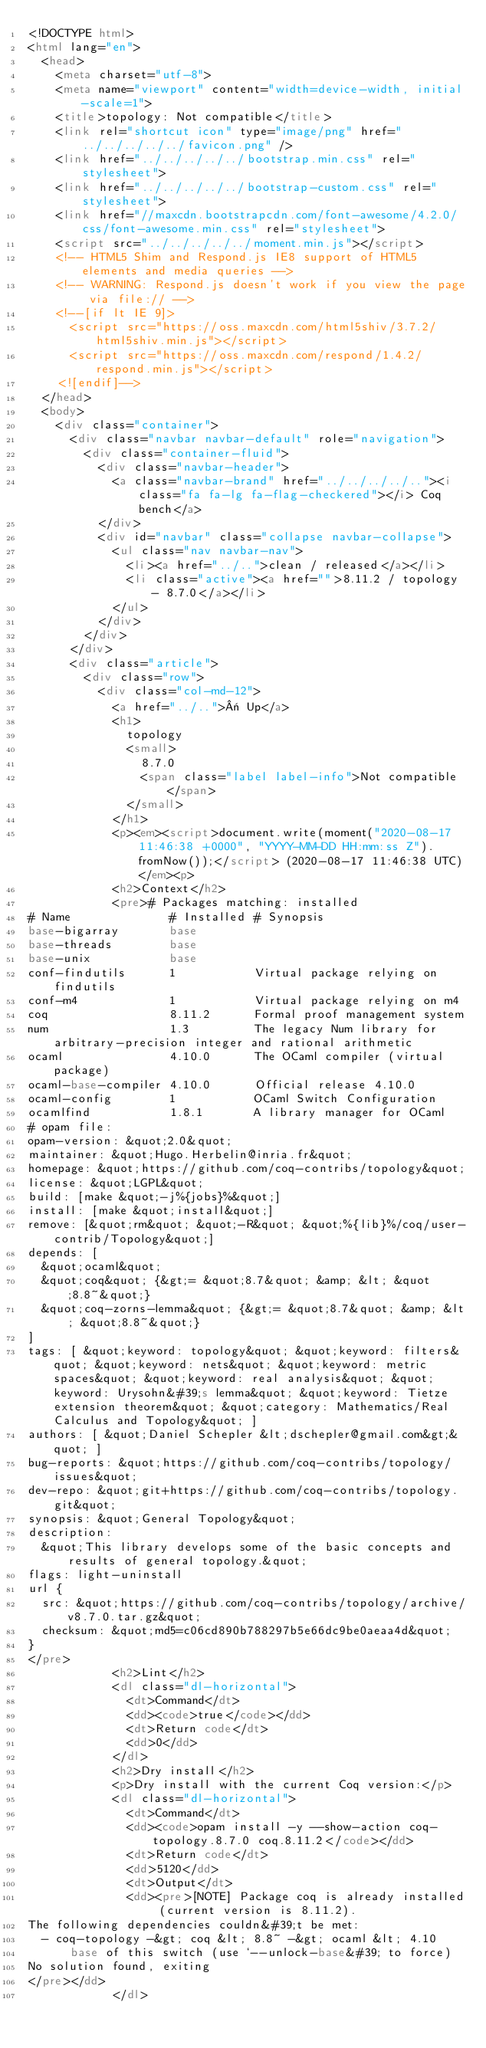Convert code to text. <code><loc_0><loc_0><loc_500><loc_500><_HTML_><!DOCTYPE html>
<html lang="en">
  <head>
    <meta charset="utf-8">
    <meta name="viewport" content="width=device-width, initial-scale=1">
    <title>topology: Not compatible</title>
    <link rel="shortcut icon" type="image/png" href="../../../../../favicon.png" />
    <link href="../../../../../bootstrap.min.css" rel="stylesheet">
    <link href="../../../../../bootstrap-custom.css" rel="stylesheet">
    <link href="//maxcdn.bootstrapcdn.com/font-awesome/4.2.0/css/font-awesome.min.css" rel="stylesheet">
    <script src="../../../../../moment.min.js"></script>
    <!-- HTML5 Shim and Respond.js IE8 support of HTML5 elements and media queries -->
    <!-- WARNING: Respond.js doesn't work if you view the page via file:// -->
    <!--[if lt IE 9]>
      <script src="https://oss.maxcdn.com/html5shiv/3.7.2/html5shiv.min.js"></script>
      <script src="https://oss.maxcdn.com/respond/1.4.2/respond.min.js"></script>
    <![endif]-->
  </head>
  <body>
    <div class="container">
      <div class="navbar navbar-default" role="navigation">
        <div class="container-fluid">
          <div class="navbar-header">
            <a class="navbar-brand" href="../../../../.."><i class="fa fa-lg fa-flag-checkered"></i> Coq bench</a>
          </div>
          <div id="navbar" class="collapse navbar-collapse">
            <ul class="nav navbar-nav">
              <li><a href="../..">clean / released</a></li>
              <li class="active"><a href="">8.11.2 / topology - 8.7.0</a></li>
            </ul>
          </div>
        </div>
      </div>
      <div class="article">
        <div class="row">
          <div class="col-md-12">
            <a href="../..">« Up</a>
            <h1>
              topology
              <small>
                8.7.0
                <span class="label label-info">Not compatible</span>
              </small>
            </h1>
            <p><em><script>document.write(moment("2020-08-17 11:46:38 +0000", "YYYY-MM-DD HH:mm:ss Z").fromNow());</script> (2020-08-17 11:46:38 UTC)</em><p>
            <h2>Context</h2>
            <pre># Packages matching: installed
# Name              # Installed # Synopsis
base-bigarray       base
base-threads        base
base-unix           base
conf-findutils      1           Virtual package relying on findutils
conf-m4             1           Virtual package relying on m4
coq                 8.11.2      Formal proof management system
num                 1.3         The legacy Num library for arbitrary-precision integer and rational arithmetic
ocaml               4.10.0      The OCaml compiler (virtual package)
ocaml-base-compiler 4.10.0      Official release 4.10.0
ocaml-config        1           OCaml Switch Configuration
ocamlfind           1.8.1       A library manager for OCaml
# opam file:
opam-version: &quot;2.0&quot;
maintainer: &quot;Hugo.Herbelin@inria.fr&quot;
homepage: &quot;https://github.com/coq-contribs/topology&quot;
license: &quot;LGPL&quot;
build: [make &quot;-j%{jobs}%&quot;]
install: [make &quot;install&quot;]
remove: [&quot;rm&quot; &quot;-R&quot; &quot;%{lib}%/coq/user-contrib/Topology&quot;]
depends: [
  &quot;ocaml&quot;
  &quot;coq&quot; {&gt;= &quot;8.7&quot; &amp; &lt; &quot;8.8~&quot;}
  &quot;coq-zorns-lemma&quot; {&gt;= &quot;8.7&quot; &amp; &lt; &quot;8.8~&quot;}
]
tags: [ &quot;keyword: topology&quot; &quot;keyword: filters&quot; &quot;keyword: nets&quot; &quot;keyword: metric spaces&quot; &quot;keyword: real analysis&quot; &quot;keyword: Urysohn&#39;s lemma&quot; &quot;keyword: Tietze extension theorem&quot; &quot;category: Mathematics/Real Calculus and Topology&quot; ]
authors: [ &quot;Daniel Schepler &lt;dschepler@gmail.com&gt;&quot; ]
bug-reports: &quot;https://github.com/coq-contribs/topology/issues&quot;
dev-repo: &quot;git+https://github.com/coq-contribs/topology.git&quot;
synopsis: &quot;General Topology&quot;
description:
  &quot;This library develops some of the basic concepts and results of general topology.&quot;
flags: light-uninstall
url {
  src: &quot;https://github.com/coq-contribs/topology/archive/v8.7.0.tar.gz&quot;
  checksum: &quot;md5=c06cd890b788297b5e66dc9be0aeaa4d&quot;
}
</pre>
            <h2>Lint</h2>
            <dl class="dl-horizontal">
              <dt>Command</dt>
              <dd><code>true</code></dd>
              <dt>Return code</dt>
              <dd>0</dd>
            </dl>
            <h2>Dry install</h2>
            <p>Dry install with the current Coq version:</p>
            <dl class="dl-horizontal">
              <dt>Command</dt>
              <dd><code>opam install -y --show-action coq-topology.8.7.0 coq.8.11.2</code></dd>
              <dt>Return code</dt>
              <dd>5120</dd>
              <dt>Output</dt>
              <dd><pre>[NOTE] Package coq is already installed (current version is 8.11.2).
The following dependencies couldn&#39;t be met:
  - coq-topology -&gt; coq &lt; 8.8~ -&gt; ocaml &lt; 4.10
      base of this switch (use `--unlock-base&#39; to force)
No solution found, exiting
</pre></dd>
            </dl></code> 